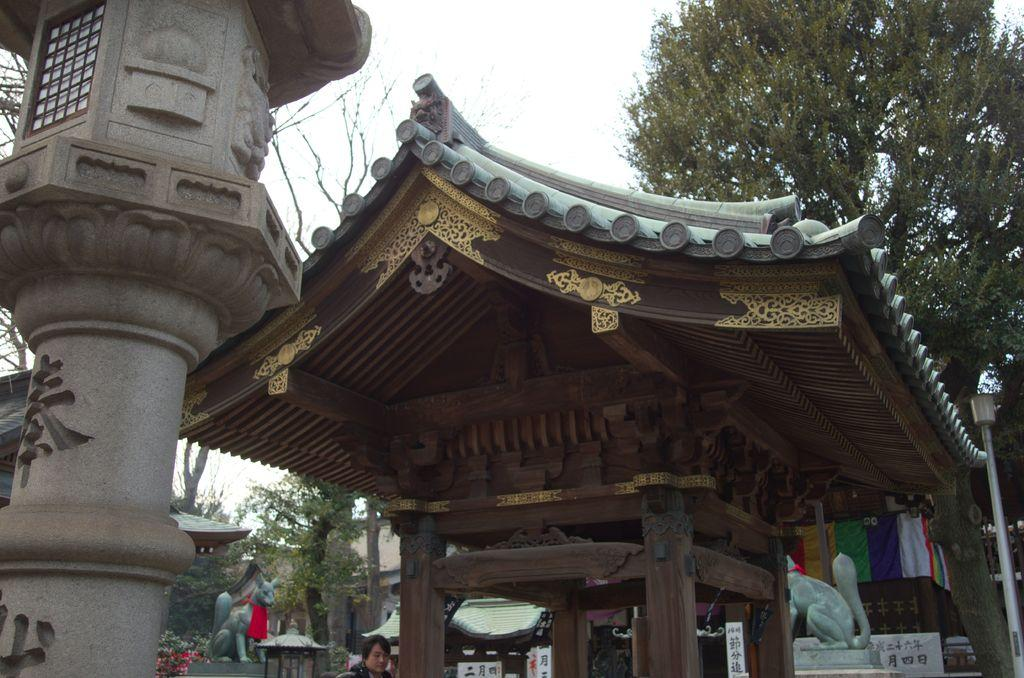What type of structure is in the picture? There is a house in the picture. What other objects can be seen in the picture? There are statues of animals, trees, plants, a pole, and a person in the picture. What can be seen in the background of the picture? The sky is visible in the background of the picture. What type of shirt is the cook wearing in the picture? There is no cook present in the picture, so it is not possible to determine what type of shirt they might be wearing. 